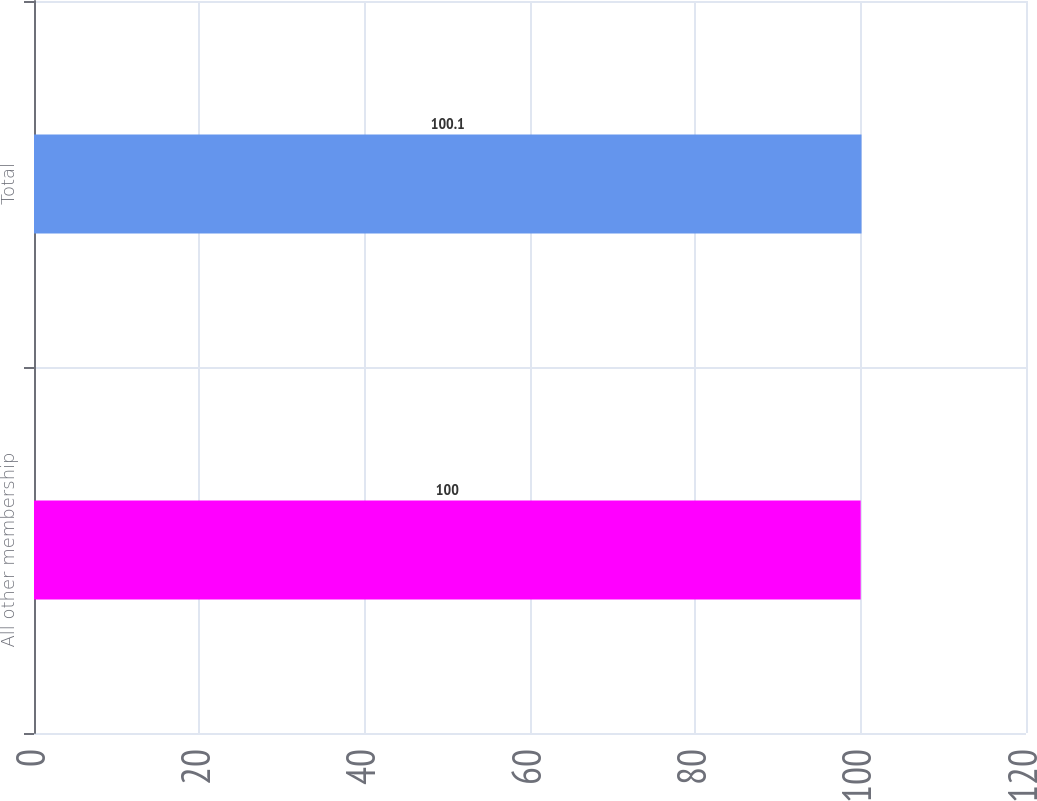Convert chart to OTSL. <chart><loc_0><loc_0><loc_500><loc_500><bar_chart><fcel>All other membership<fcel>Total<nl><fcel>100<fcel>100.1<nl></chart> 